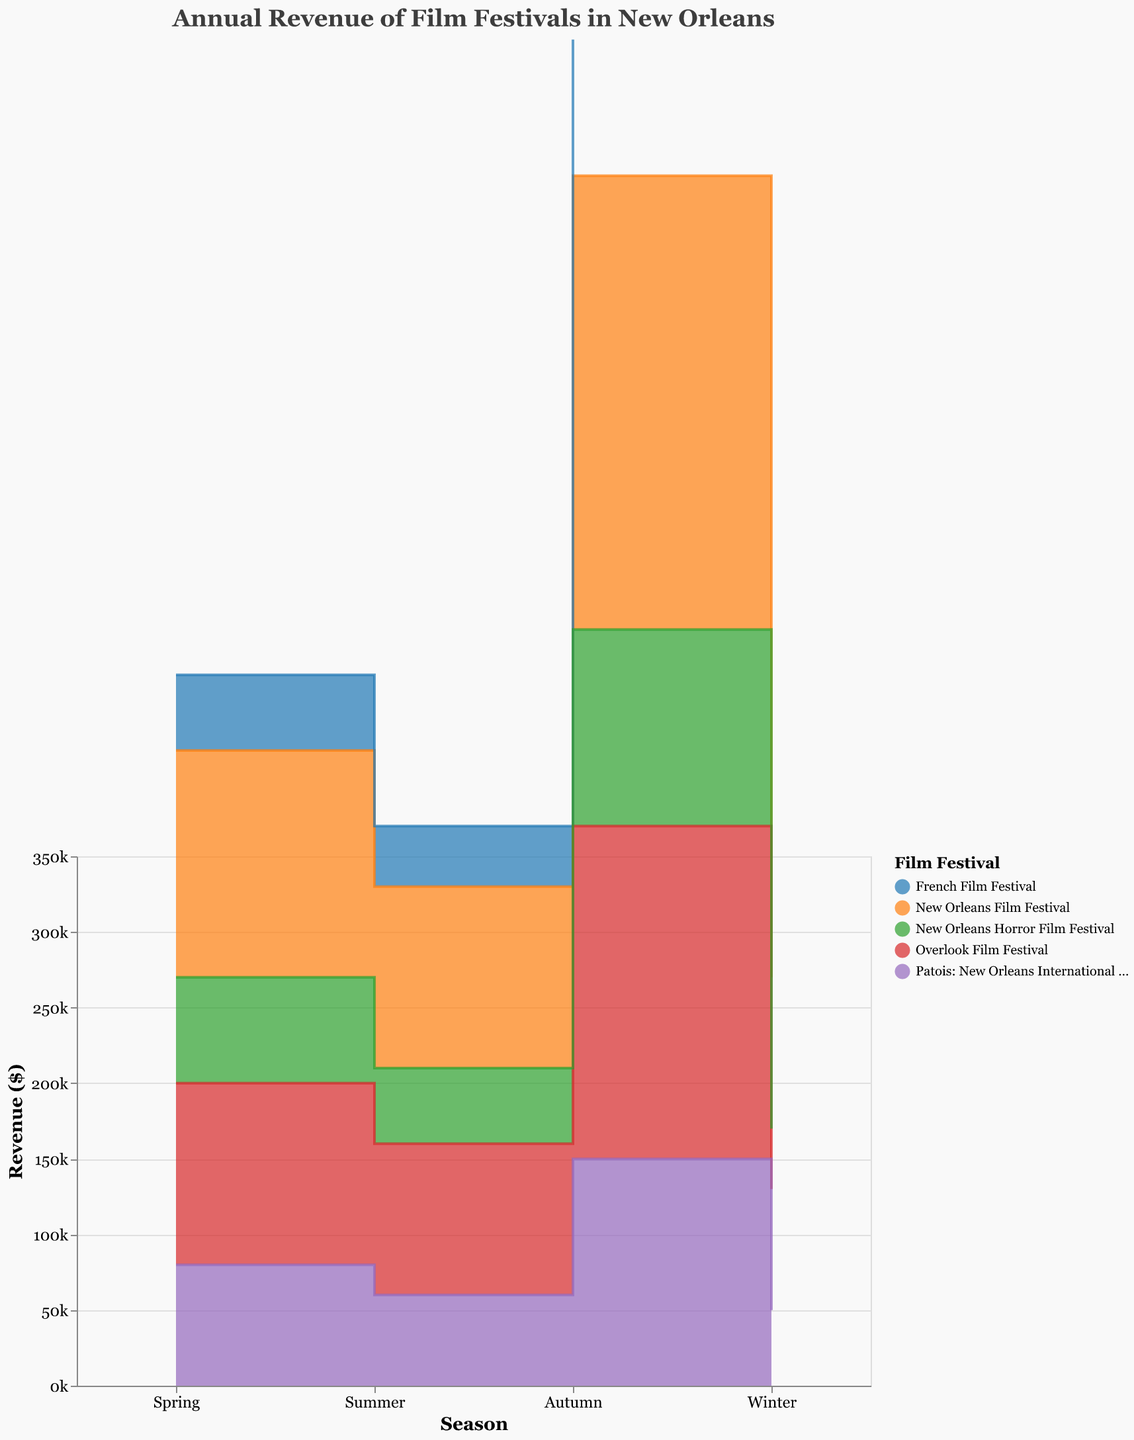What is the title of the chart? The title is usually displayed at the top of the chart and provides a brief description of what the chart represents. In this case, it reads "Annual Revenue of Film Festivals in New Orleans".
Answer: Annual Revenue of Film Festivals in New Orleans Which film festival has the highest revenue in Autumn? To determine which film festival has the highest revenue in Autumn, we look at the Autumn portion of the chart and identify the festival with the highest value. The New Orleans Film Festival has the highest revenue in Autumn with $300,000.
Answer: New Orleans Film Festival What is the total revenue for the New Orleans Film Festival across all seasons? To calculate the total revenue, sum the revenue for all seasons: Spring ($150,000) + Summer ($120,000) + Autumn ($300,000) + Winter ($100,000). The sum is $150,000 + $120,000 + $300,000 + $100,000 = $670,000.
Answer: $670,000 Which festival shows the least variation in revenue across different seasons? The least variation means the difference between the highest and lowest revenue points is minimal. For each festival, observe the revenues across seasons. The French Film Festival has the most consistent revenue, ranging from $30,000 to $90,000.
Answer: French Film Festival In which season does the Overlook Film Festival earn the highest revenue? Look at the revenue values for the Overlook Film Festival across all seasons and identify the highest value. For the Overlook Film Festival, the highest revenue is in Autumn with $220,000.
Answer: Autumn What is the difference in revenue between Spring and Winter for Patois: New Orleans International Human Rights Film Festival? Subtract the Winter revenue from the Spring revenue for Patois: New Orleans International Human Rights Film Festival. Spring ($80,000) - Winter ($50,000). The difference is $80,000 - $50,000 = $30,000.
Answer: $30,000 Compare the Summer revenues of the French Film Festival and the New Orleans Horror Film Festival. Which one is higher and by how much? Look at the Summer revenue for both festivals: French Film Festival ($40,000) and New Orleans Horror Film Festival ($50,000). The New Orleans Horror Film Festival's Summer revenue is higher by $50,000 - $40,000 = $10,000.
Answer: New Orleans Horror Film Festival by $10,000 What is the average revenue for the New Orleans Horror Film Festival across all seasons? Calculate the average by summing the revenues for all seasons and dividing by the number of seasons: ($70,000 + $50,000 + $130,000 + $40,000) / 4. The average is ($70,000 + $50,000 + $130,000 + $40,000) / 4 = $72,500.
Answer: $72,500 Which season overall has the highest combined revenue for all festivals? To find the season with the highest combined revenue, sum the revenues for each season across all festivals and compare the totals. Spring ($150,000 + $50,000 + $120,000 + $80,000 + $70,000), Summer ($120,000 + $40,000 + $100,000 + $60,000 + $50,000), Autumn ($300,000 + $90,000 + $220,000 + $150,000 + $130,000), Winter ($100,000 + $30,000 + $80,000 + $50,000 + $40,000). The Autumn season has the highest combined revenue: $470,000 + $370,000 + $890,000 + $300,000 = $2,030,000.
Answer: Autumn What is the combined revenue of all festivals in Winter? Sum the Winter revenues of each festival: New Orleans Film Festival ($100,000) + French Film Festival ($30,000) + Overlook Film Festival ($80,000) + Patois: New Orleans International Human Rights Film Festival ($50,000) + New Orleans Horror Film Festival ($40,000). The combined revenue for Winter is $100,000 + $30,000 + $80,000 + $50,000 + $40,000 = $300,000.
Answer: $300,000 